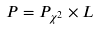Convert formula to latex. <formula><loc_0><loc_0><loc_500><loc_500>P = P _ { \chi ^ { 2 } } \times L</formula> 